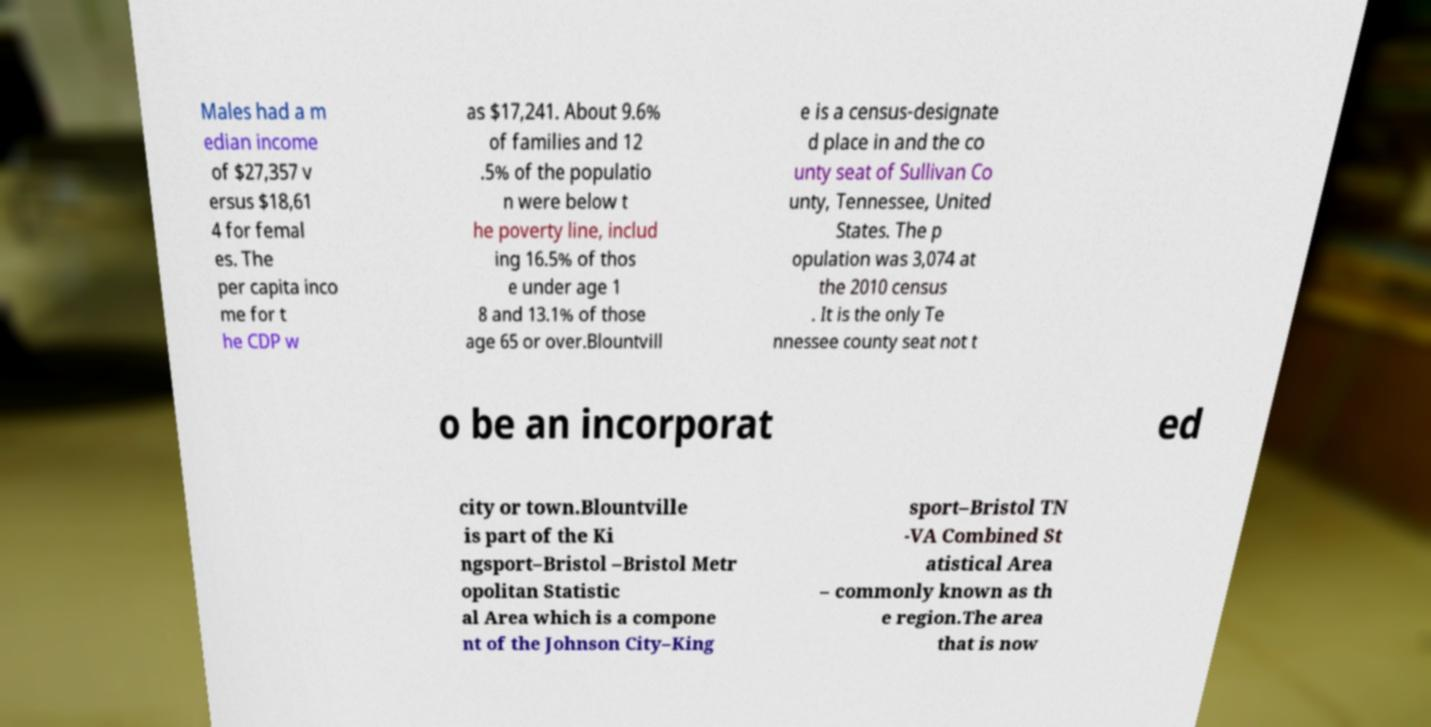Could you assist in decoding the text presented in this image and type it out clearly? Males had a m edian income of $27,357 v ersus $18,61 4 for femal es. The per capita inco me for t he CDP w as $17,241. About 9.6% of families and 12 .5% of the populatio n were below t he poverty line, includ ing 16.5% of thos e under age 1 8 and 13.1% of those age 65 or over.Blountvill e is a census-designate d place in and the co unty seat of Sullivan Co unty, Tennessee, United States. The p opulation was 3,074 at the 2010 census . It is the only Te nnessee county seat not t o be an incorporat ed city or town.Blountville is part of the Ki ngsport–Bristol –Bristol Metr opolitan Statistic al Area which is a compone nt of the Johnson City–King sport–Bristol TN -VA Combined St atistical Area – commonly known as th e region.The area that is now 